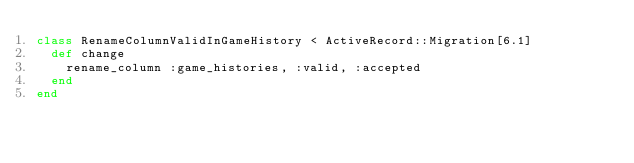Convert code to text. <code><loc_0><loc_0><loc_500><loc_500><_Ruby_>class RenameColumnValidInGameHistory < ActiveRecord::Migration[6.1]
  def change
    rename_column :game_histories, :valid, :accepted
  end
end
</code> 